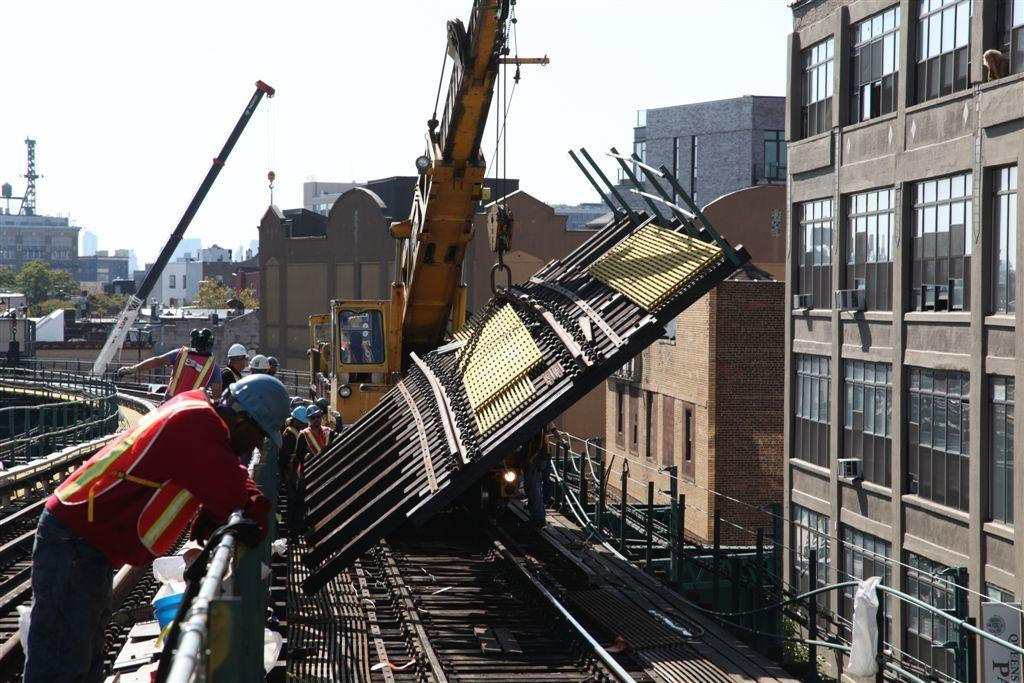What can be seen in the left corner of the image? There are persons in the left corner of the image. What type of machinery is present in the image? There is a crane in the image. What is positioned in front of the crane? There is an object in front of the crane. What type of structures are visible in the background of the image? There are buildings in the background of the image. What type of vegetation is visible in the background of the image? There are trees in the background of the image. What type of skirt is being worn by the crane in the image? There is no skirt present in the image, as the crane is a piece of machinery and not a person. How many beads can be seen hanging from the object in front of the crane? There is no mention of beads in the image, so it is impossible to determine their presence or quantity. 